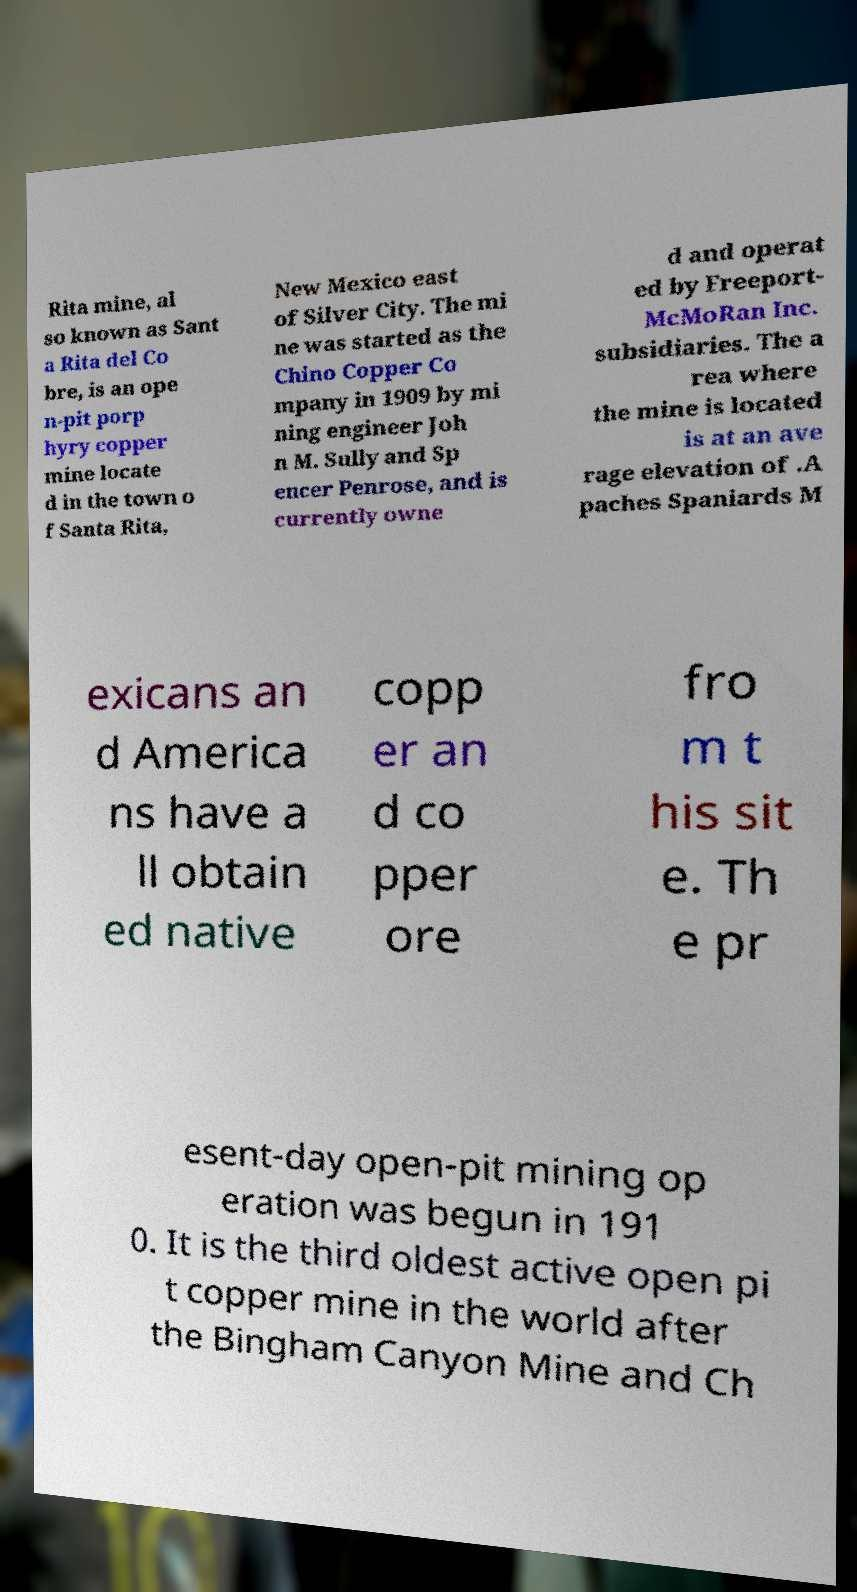For documentation purposes, I need the text within this image transcribed. Could you provide that? Rita mine, al so known as Sant a Rita del Co bre, is an ope n-pit porp hyry copper mine locate d in the town o f Santa Rita, New Mexico east of Silver City. The mi ne was started as the Chino Copper Co mpany in 1909 by mi ning engineer Joh n M. Sully and Sp encer Penrose, and is currently owne d and operat ed by Freeport- McMoRan Inc. subsidiaries. The a rea where the mine is located is at an ave rage elevation of .A paches Spaniards M exicans an d America ns have a ll obtain ed native copp er an d co pper ore fro m t his sit e. Th e pr esent-day open-pit mining op eration was begun in 191 0. It is the third oldest active open pi t copper mine in the world after the Bingham Canyon Mine and Ch 